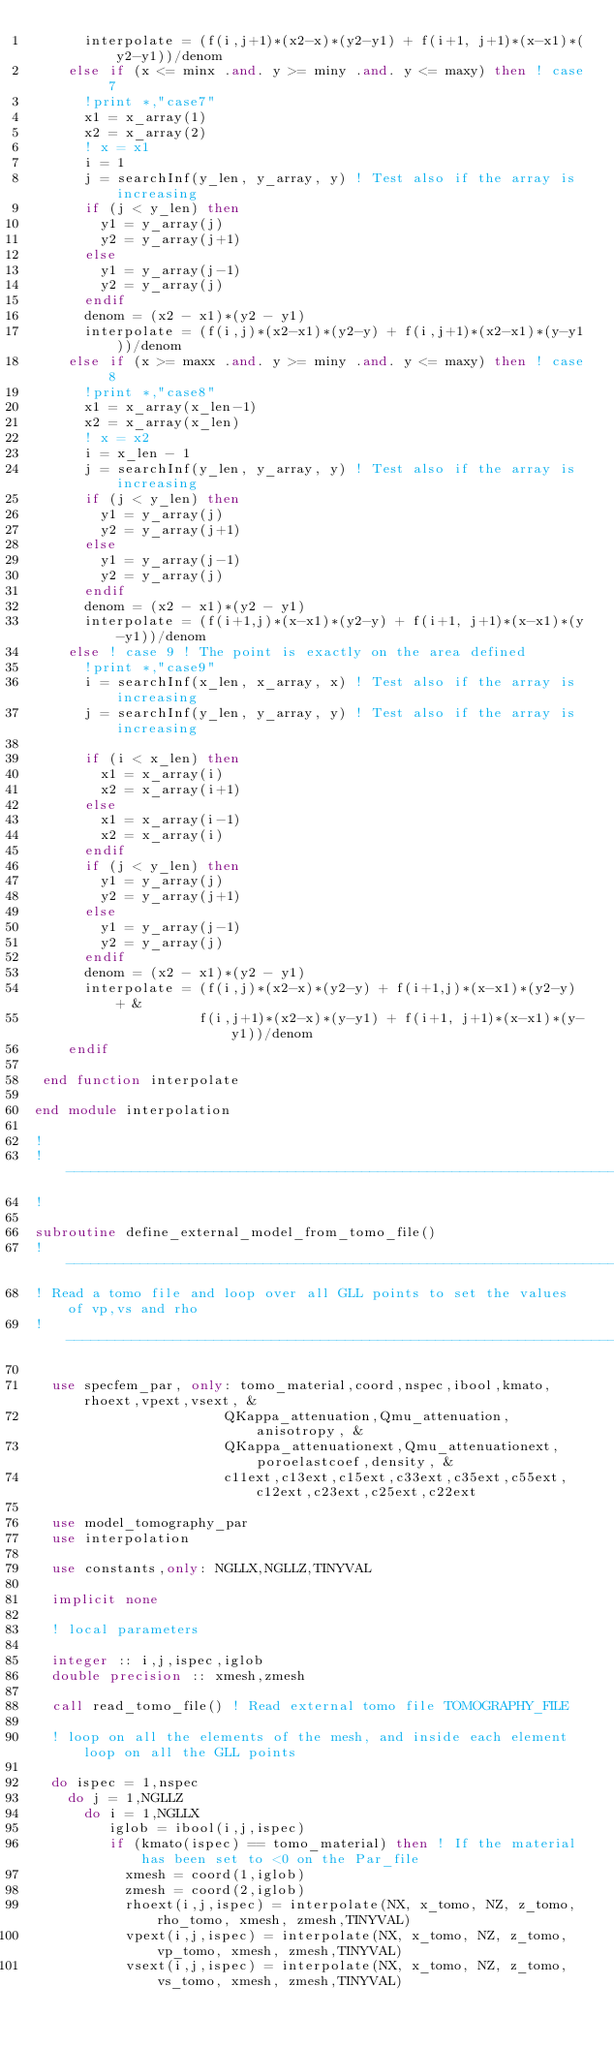Convert code to text. <code><loc_0><loc_0><loc_500><loc_500><_FORTRAN_>      interpolate = (f(i,j+1)*(x2-x)*(y2-y1) + f(i+1, j+1)*(x-x1)*(y2-y1))/denom
    else if (x <= minx .and. y >= miny .and. y <= maxy) then ! case 7
      !print *,"case7"
      x1 = x_array(1)
      x2 = x_array(2)
      ! x = x1
      i = 1
      j = searchInf(y_len, y_array, y) ! Test also if the array is increasing
      if (j < y_len) then
        y1 = y_array(j)
        y2 = y_array(j+1)
      else
        y1 = y_array(j-1)
        y2 = y_array(j)
      endif
      denom = (x2 - x1)*(y2 - y1)
      interpolate = (f(i,j)*(x2-x1)*(y2-y) + f(i,j+1)*(x2-x1)*(y-y1))/denom
    else if (x >= maxx .and. y >= miny .and. y <= maxy) then ! case 8
      !print *,"case8"
      x1 = x_array(x_len-1)
      x2 = x_array(x_len)
      ! x = x2
      i = x_len - 1
      j = searchInf(y_len, y_array, y) ! Test also if the array is increasing
      if (j < y_len) then
        y1 = y_array(j)
        y2 = y_array(j+1)
      else
        y1 = y_array(j-1)
        y2 = y_array(j)
      endif
      denom = (x2 - x1)*(y2 - y1)
      interpolate = (f(i+1,j)*(x-x1)*(y2-y) + f(i+1, j+1)*(x-x1)*(y-y1))/denom
    else ! case 9 ! The point is exactly on the area defined
      !print *,"case9"
      i = searchInf(x_len, x_array, x) ! Test also if the array is increasing
      j = searchInf(y_len, y_array, y) ! Test also if the array is increasing

      if (i < x_len) then
        x1 = x_array(i)
        x2 = x_array(i+1)
      else
        x1 = x_array(i-1)
        x2 = x_array(i)
      endif
      if (j < y_len) then
        y1 = y_array(j)
        y2 = y_array(j+1)
      else
        y1 = y_array(j-1)
        y2 = y_array(j)
      endif
      denom = (x2 - x1)*(y2 - y1)
      interpolate = (f(i,j)*(x2-x)*(y2-y) + f(i+1,j)*(x-x1)*(y2-y) + &
                    f(i,j+1)*(x2-x)*(y-y1) + f(i+1, j+1)*(x-x1)*(y-y1))/denom
    endif

 end function interpolate

end module interpolation

!
! ----------------------------------------------------------------------------------------
!

subroutine define_external_model_from_tomo_file()
! ----------------------------------------------------------------------------------------
! Read a tomo file and loop over all GLL points to set the values of vp,vs and rho
! ----------------------------------------------------------------------------------------

  use specfem_par, only: tomo_material,coord,nspec,ibool,kmato,rhoext,vpext,vsext, &
                       QKappa_attenuation,Qmu_attenuation,anisotropy, &
                       QKappa_attenuationext,Qmu_attenuationext,poroelastcoef,density, &
                       c11ext,c13ext,c15ext,c33ext,c35ext,c55ext,c12ext,c23ext,c25ext,c22ext

  use model_tomography_par
  use interpolation

  use constants,only: NGLLX,NGLLZ,TINYVAL

  implicit none

  ! local parameters

  integer :: i,j,ispec,iglob
  double precision :: xmesh,zmesh

  call read_tomo_file() ! Read external tomo file TOMOGRAPHY_FILE

  ! loop on all the elements of the mesh, and inside each element loop on all the GLL points

  do ispec = 1,nspec
    do j = 1,NGLLZ
      do i = 1,NGLLX
         iglob = ibool(i,j,ispec)
         if (kmato(ispec) == tomo_material) then ! If the material has been set to <0 on the Par_file
           xmesh = coord(1,iglob)
           zmesh = coord(2,iglob)
           rhoext(i,j,ispec) = interpolate(NX, x_tomo, NZ, z_tomo, rho_tomo, xmesh, zmesh,TINYVAL)
           vpext(i,j,ispec) = interpolate(NX, x_tomo, NZ, z_tomo, vp_tomo, xmesh, zmesh,TINYVAL)
           vsext(i,j,ispec) = interpolate(NX, x_tomo, NZ, z_tomo, vs_tomo, xmesh, zmesh,TINYVAL)</code> 